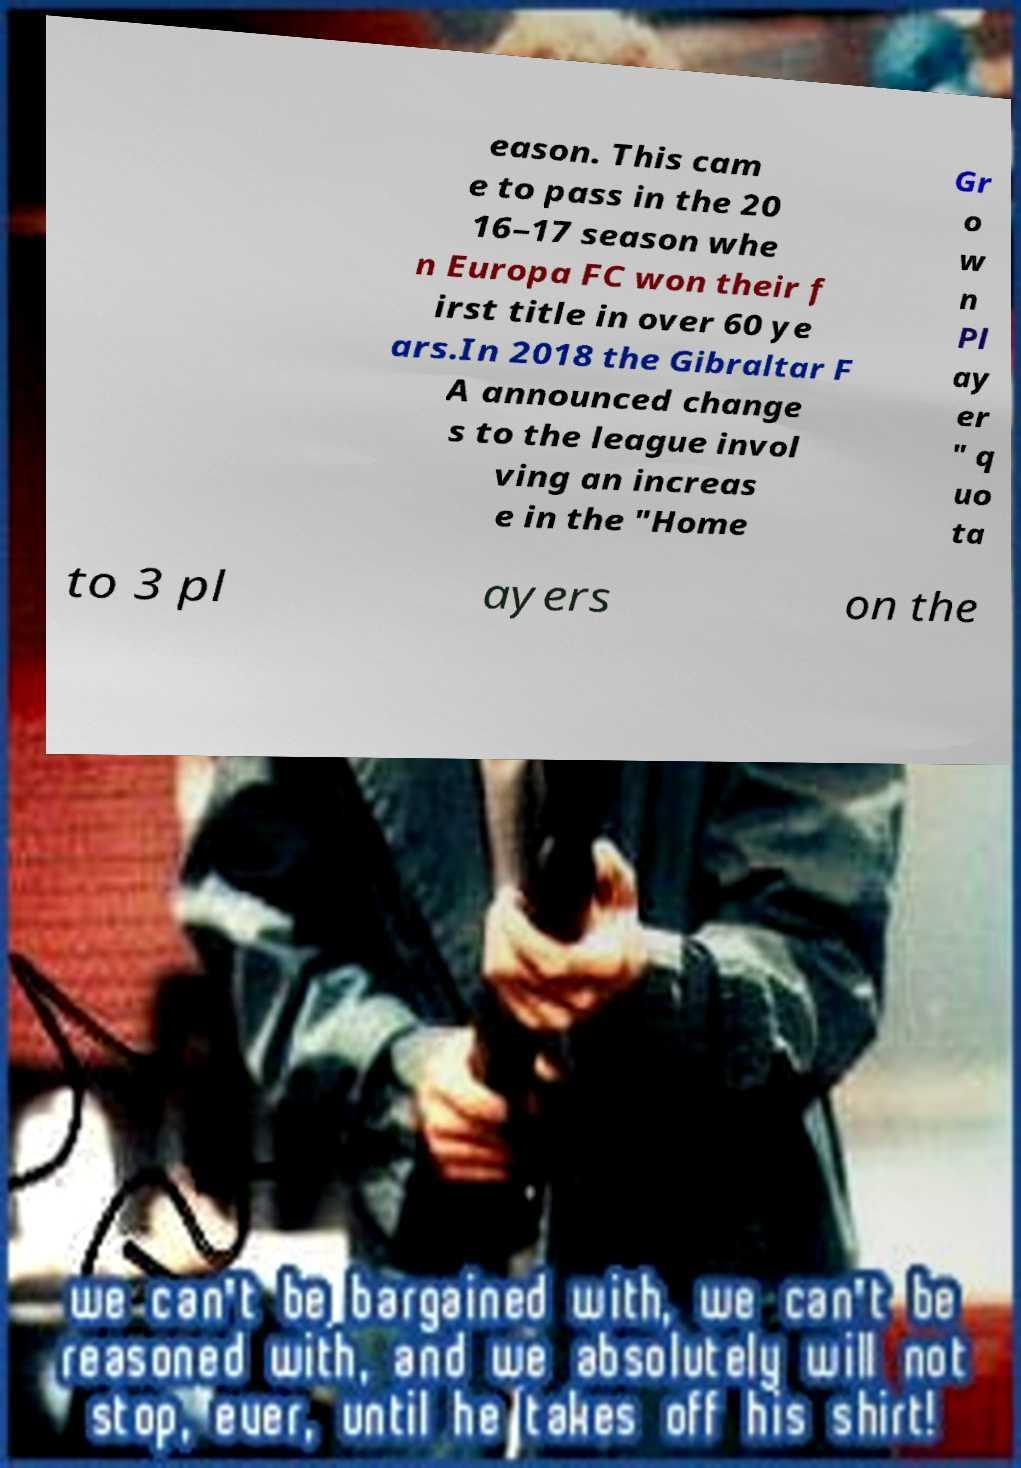Please read and relay the text visible in this image. What does it say? eason. This cam e to pass in the 20 16–17 season whe n Europa FC won their f irst title in over 60 ye ars.In 2018 the Gibraltar F A announced change s to the league invol ving an increas e in the "Home Gr o w n Pl ay er " q uo ta to 3 pl ayers on the 